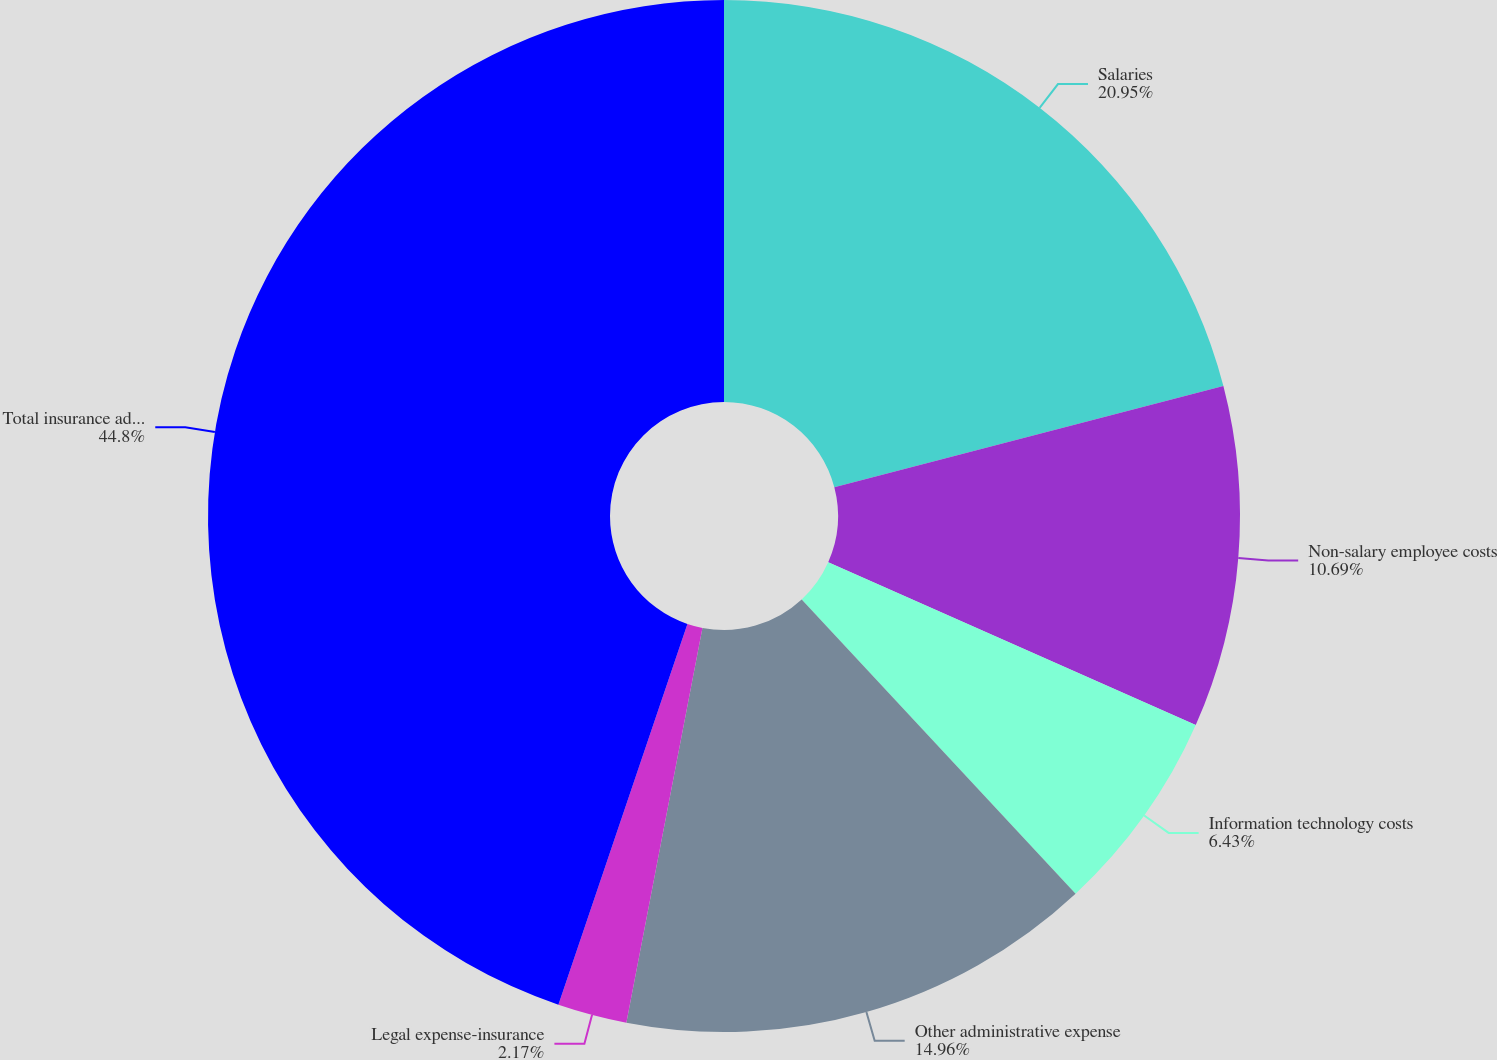Convert chart to OTSL. <chart><loc_0><loc_0><loc_500><loc_500><pie_chart><fcel>Salaries<fcel>Non-salary employee costs<fcel>Information technology costs<fcel>Other administrative expense<fcel>Legal expense-insurance<fcel>Total insurance administrative<nl><fcel>20.95%<fcel>10.69%<fcel>6.43%<fcel>14.96%<fcel>2.17%<fcel>44.8%<nl></chart> 